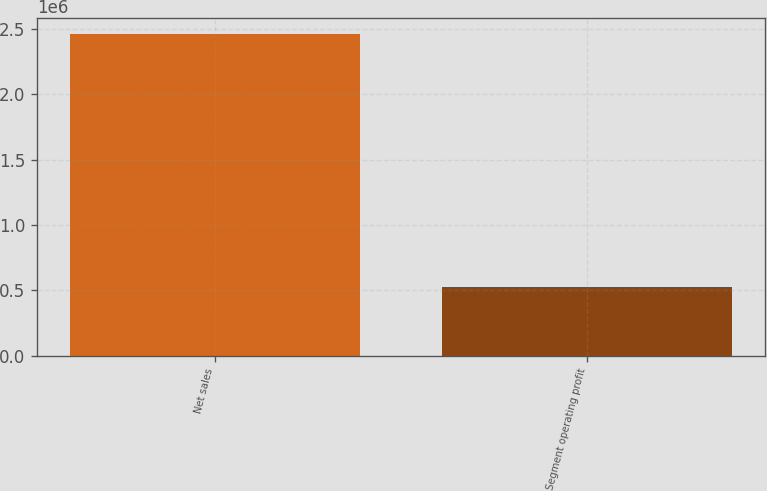<chart> <loc_0><loc_0><loc_500><loc_500><bar_chart><fcel>Net sales<fcel>Segment operating profit<nl><fcel>2.46288e+06<fcel>528038<nl></chart> 